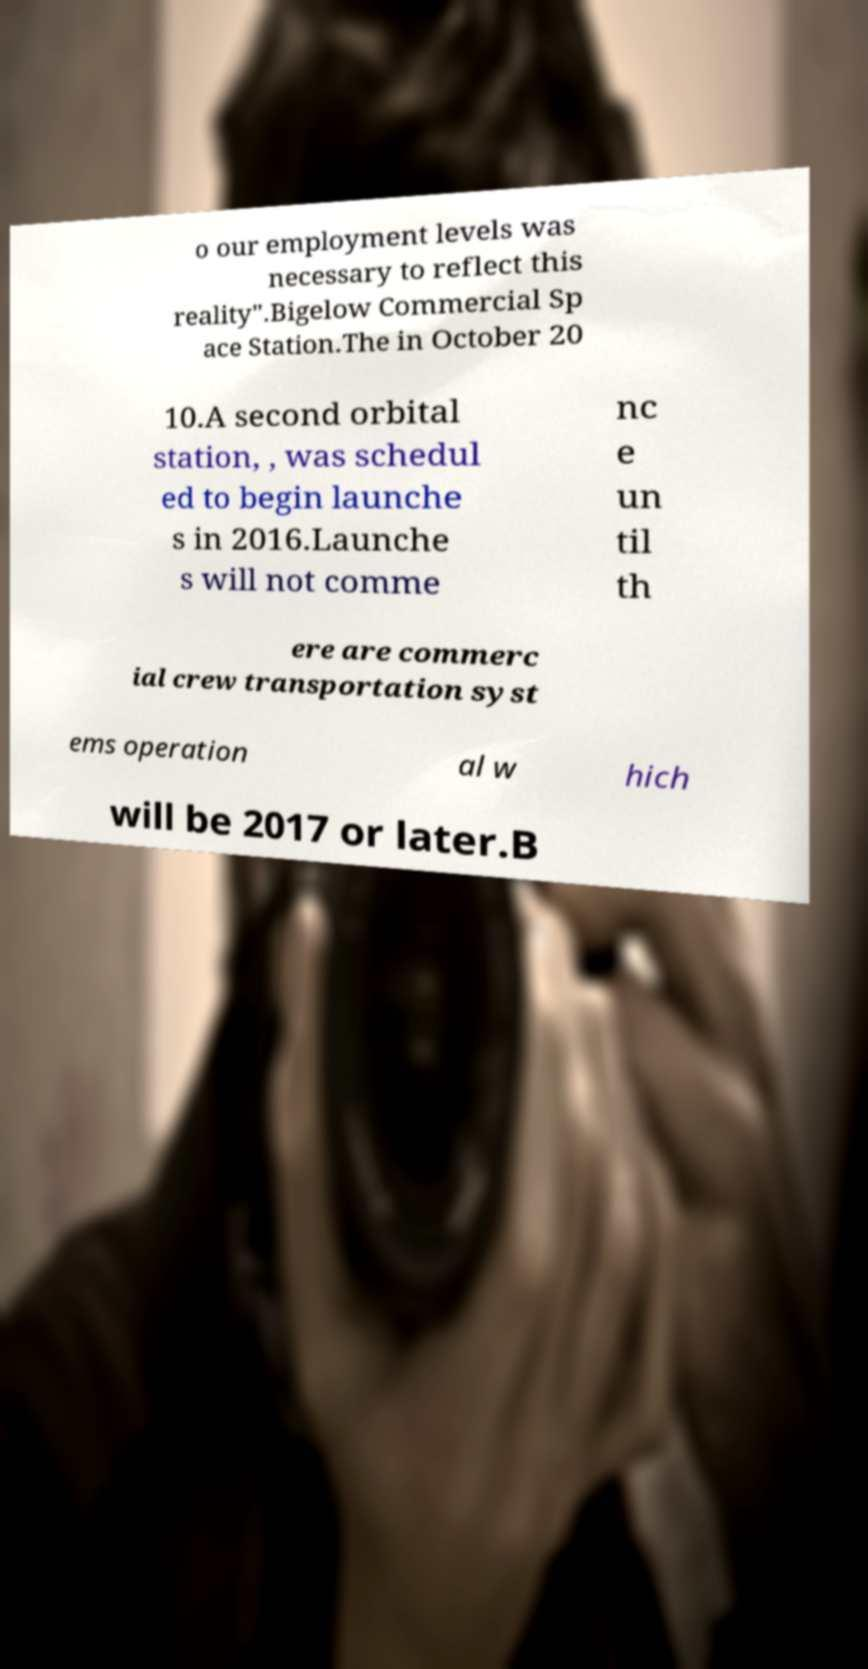Could you extract and type out the text from this image? o our employment levels was necessary to reflect this reality".Bigelow Commercial Sp ace Station.The in October 20 10.A second orbital station, , was schedul ed to begin launche s in 2016.Launche s will not comme nc e un til th ere are commerc ial crew transportation syst ems operation al w hich will be 2017 or later.B 